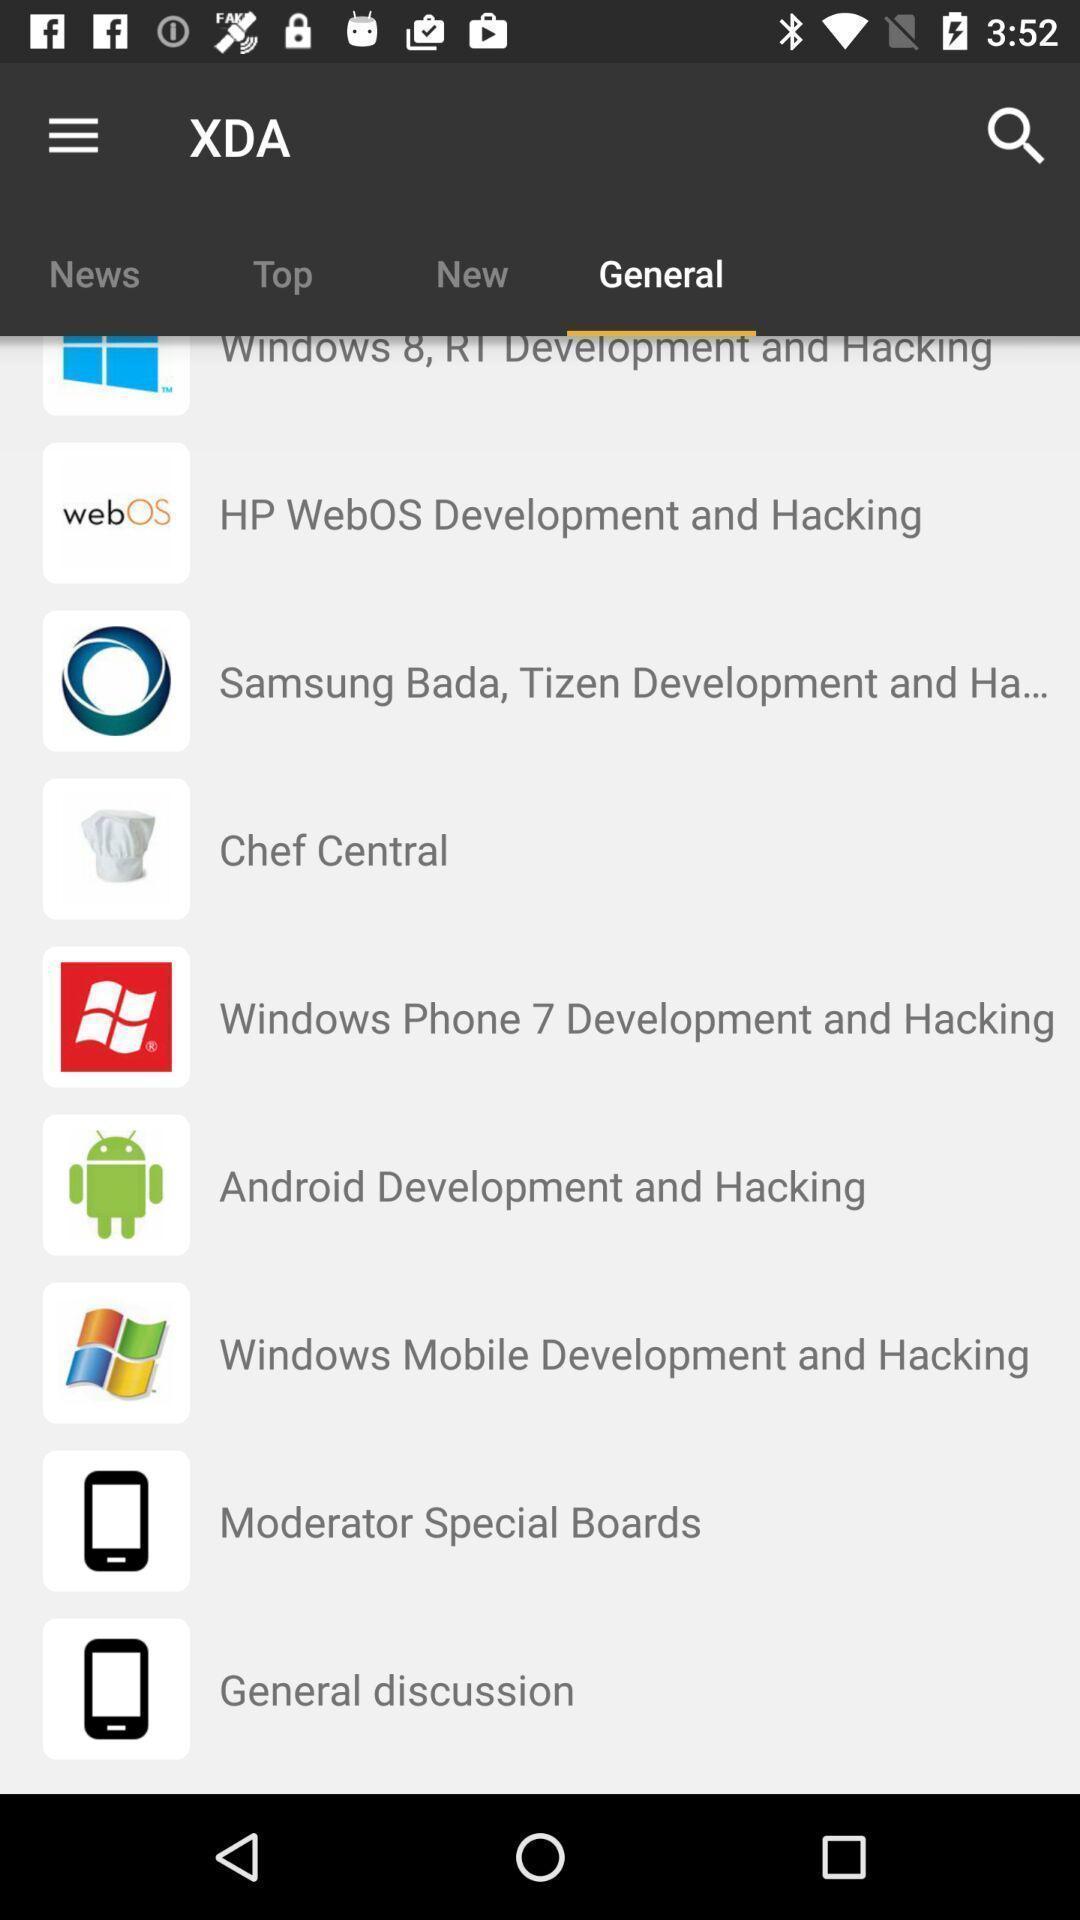Tell me about the visual elements in this screen capture. Screen shows general list. 